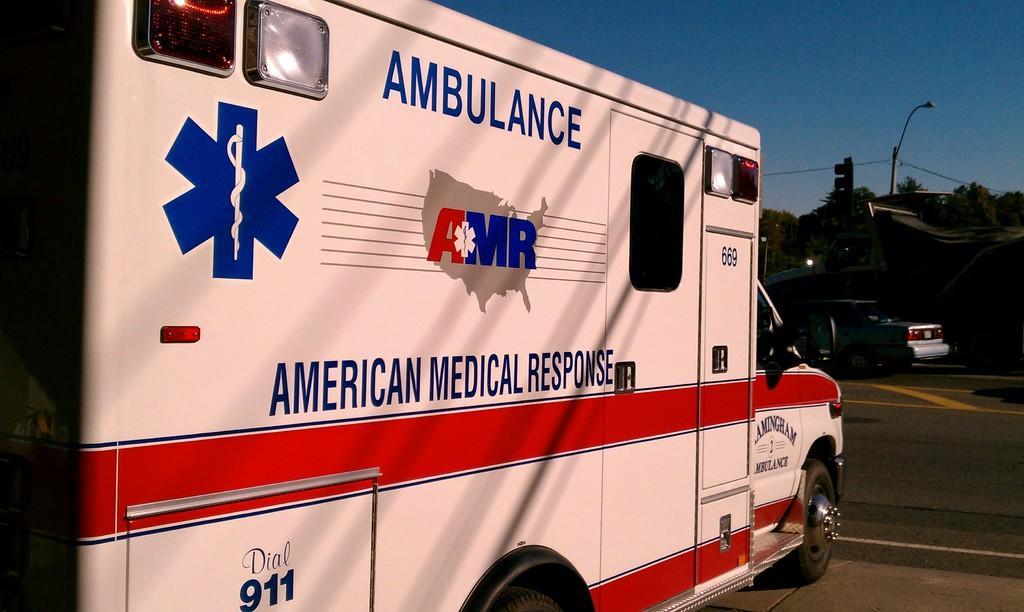Can you describe this image briefly? In this picture there are vehicles on the road and there is text on the vehicle. At the back there are trees and there are poles and there is a traffic light pole. At the top there is sky and there are wires. At the bottom there is a road. 